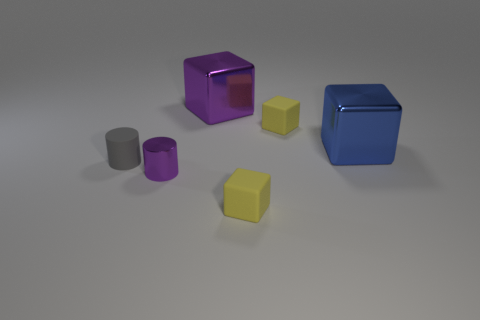Subtract all cyan cubes. Subtract all gray balls. How many cubes are left? 4 Add 3 tiny yellow rubber objects. How many objects exist? 9 Subtract all blocks. How many objects are left? 2 Subtract all big cubes. Subtract all large purple metal blocks. How many objects are left? 3 Add 5 matte objects. How many matte objects are left? 8 Add 3 blue metal objects. How many blue metal objects exist? 4 Subtract 0 brown balls. How many objects are left? 6 